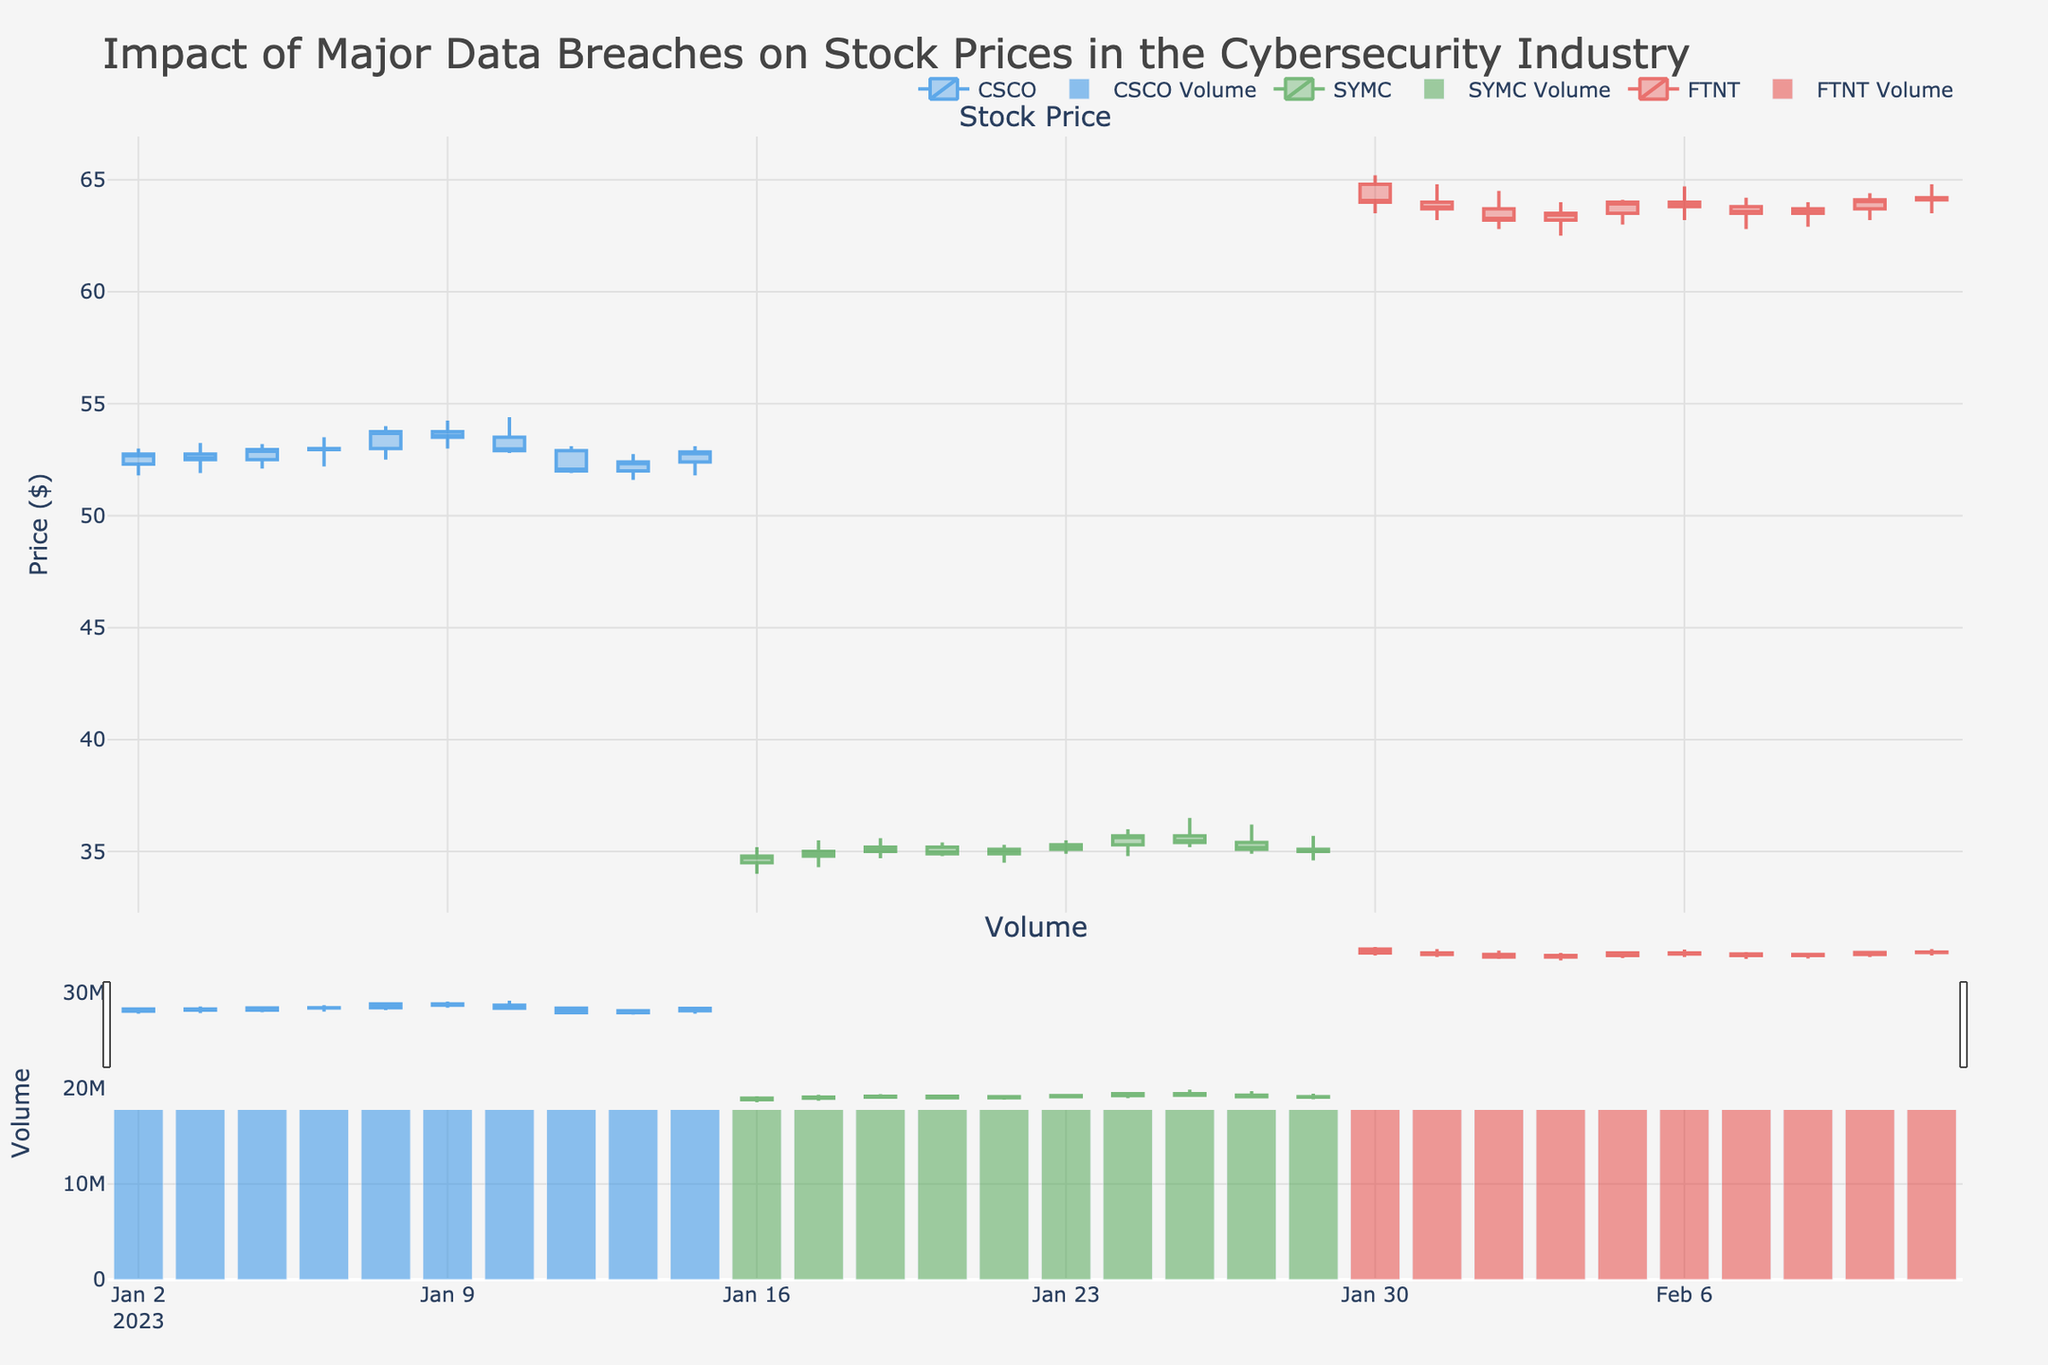Which cybersecurity company shows the highest stock price increase in a single day within the observed period? To find the highest stock price increase, compare the 'Close' prices between consecutive days for each company. CSCO on 2023-01-06 had the largest increase from $53.00 to $53.75, which is a $0.75 increase.
Answer: CSCO on 2023-01-06 How did SYMC's stock price change between January 16 and January 27? Look at the 'Close' prices for SYMC on January 16 ($34.80) and January 27 ($35.00). The price increased by $0.20.
Answer: Increased by $0.20 What is the average daily trading volume for FTNT during the observed period? Sum the 'Volume' values for FTNT from January 30 to February 10 and divide by the number of days (10). Sum = 20M + 21M + 22M + 23M + 24M + 25M + 26M + 27M + 28M + 29M = 245M, Average volume = 245M/10.
Answer: 24.5 million Which company had the highest closing price on January 25? Check the 'Close' price for each company on January 25. SYMC's closing price was $35.40, which is higher than the others.
Answer: SYMC How did CSCO's stock closing price trend over the observed period? Analyze the 'Close' prices for CSCO from January 2 to January 13. The price starts at $52.75, increases mildly and closes at $52.85 on January 13.
Answer: Mild increase Which company had the most stable stock price in terms of the smallest price range over the observed period? Calculate the price range for each company by subtracting the lowest 'Low' from the highest 'High'. FTNT range: $65.20 - $62.50 = $2.70; SYMC range: $36.50 - $34.00 = $2.50; CSCO range: $54.40 - $51.80 = $2.60. SYMC has the smallest range.
Answer: SYMC What is the maximum trading volume recorded for CSCO? Check the 'Volume' data for CSCO and find the highest value which is 33,000,000 on January 13.
Answer: 33 million 